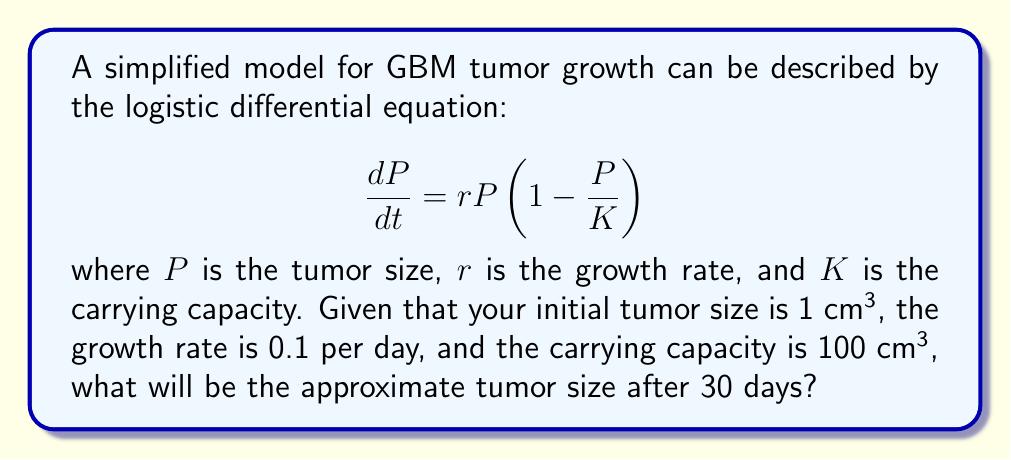Give your solution to this math problem. To solve this problem, we need to use the analytical solution of the logistic differential equation:

1) The general solution to the logistic equation is:

   $$P(t) = \frac{KP_0e^{rt}}{K + P_0(e^{rt} - 1)}$$

   where $P_0$ is the initial tumor size.

2) We are given:
   $P_0 = 1$ cm³
   $r = 0.1$ per day
   $K = 100$ cm³
   $t = 30$ days

3) Substituting these values into the equation:

   $$P(30) = \frac{100 \cdot 1 \cdot e^{0.1 \cdot 30}}{100 + 1(e^{0.1 \cdot 30} - 1)}$$

4) Simplify the exponential term:
   $e^{0.1 \cdot 30} = e^3 \approx 20.0855$

5) Substitute this value:

   $$P(30) = \frac{100 \cdot 20.0855}{100 + (20.0855 - 1)}$$

6) Simplify:

   $$P(30) = \frac{2008.55}{119.0855} \approx 16.87 \text{ cm³}$$

Therefore, after 30 days, the tumor size will be approximately 16.87 cm³.
Answer: 16.87 cm³ 